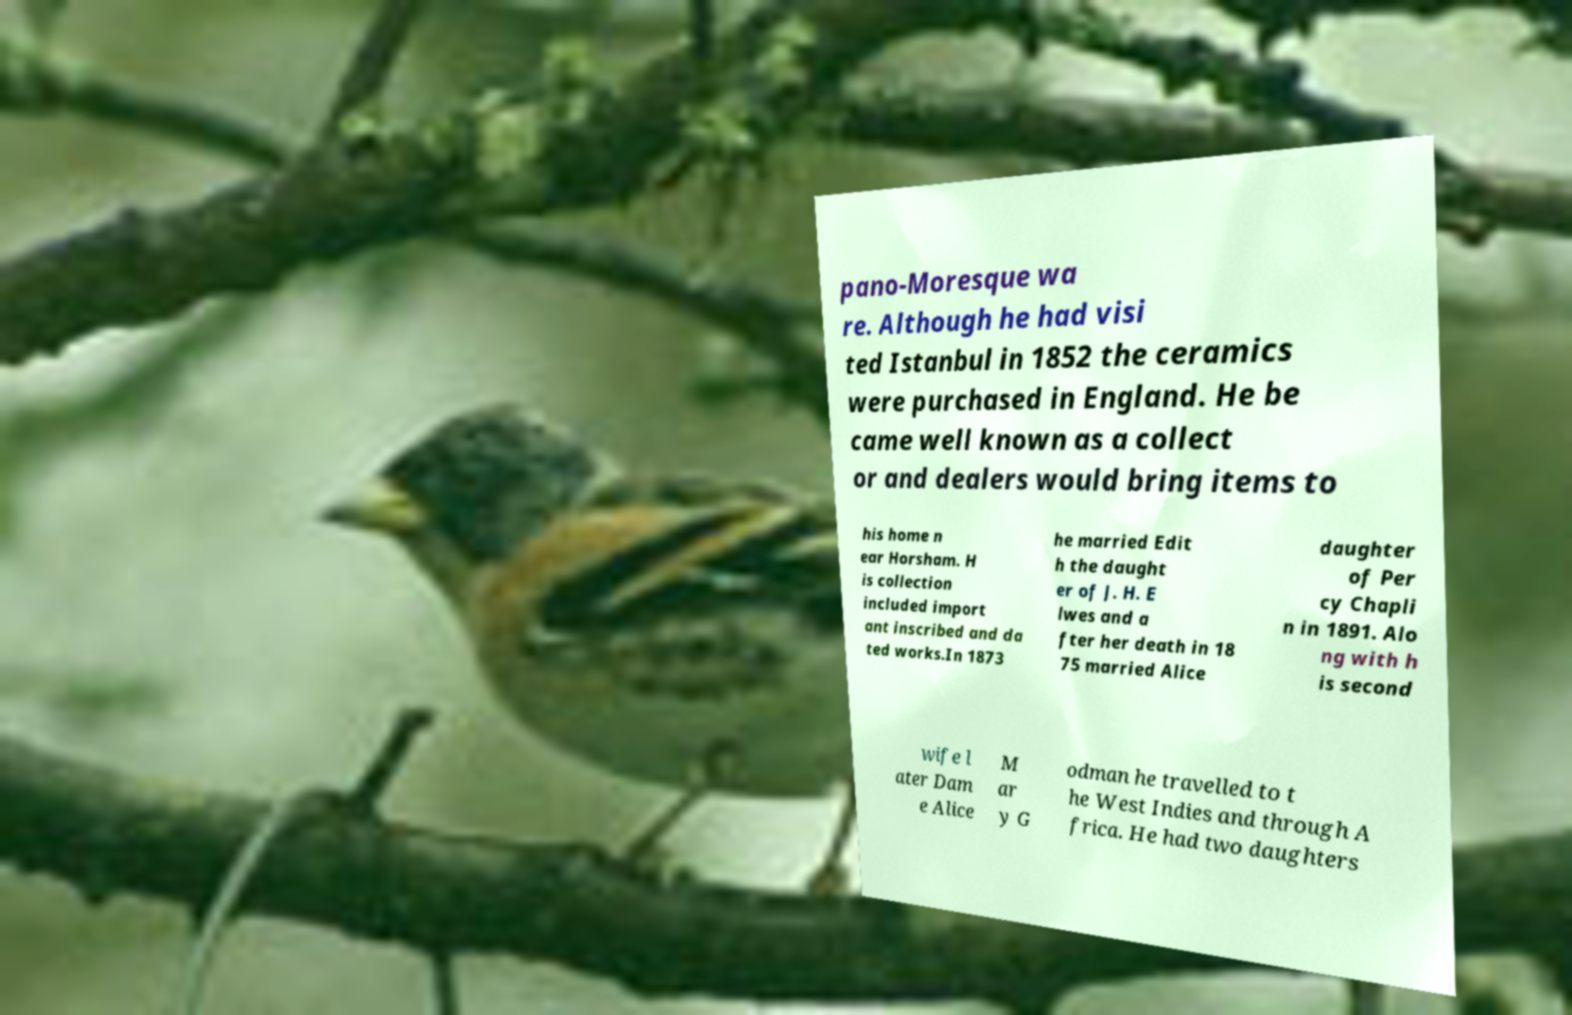What messages or text are displayed in this image? I need them in a readable, typed format. pano-Moresque wa re. Although he had visi ted Istanbul in 1852 the ceramics were purchased in England. He be came well known as a collect or and dealers would bring items to his home n ear Horsham. H is collection included import ant inscribed and da ted works.In 1873 he married Edit h the daught er of J. H. E lwes and a fter her death in 18 75 married Alice daughter of Per cy Chapli n in 1891. Alo ng with h is second wife l ater Dam e Alice M ar y G odman he travelled to t he West Indies and through A frica. He had two daughters 